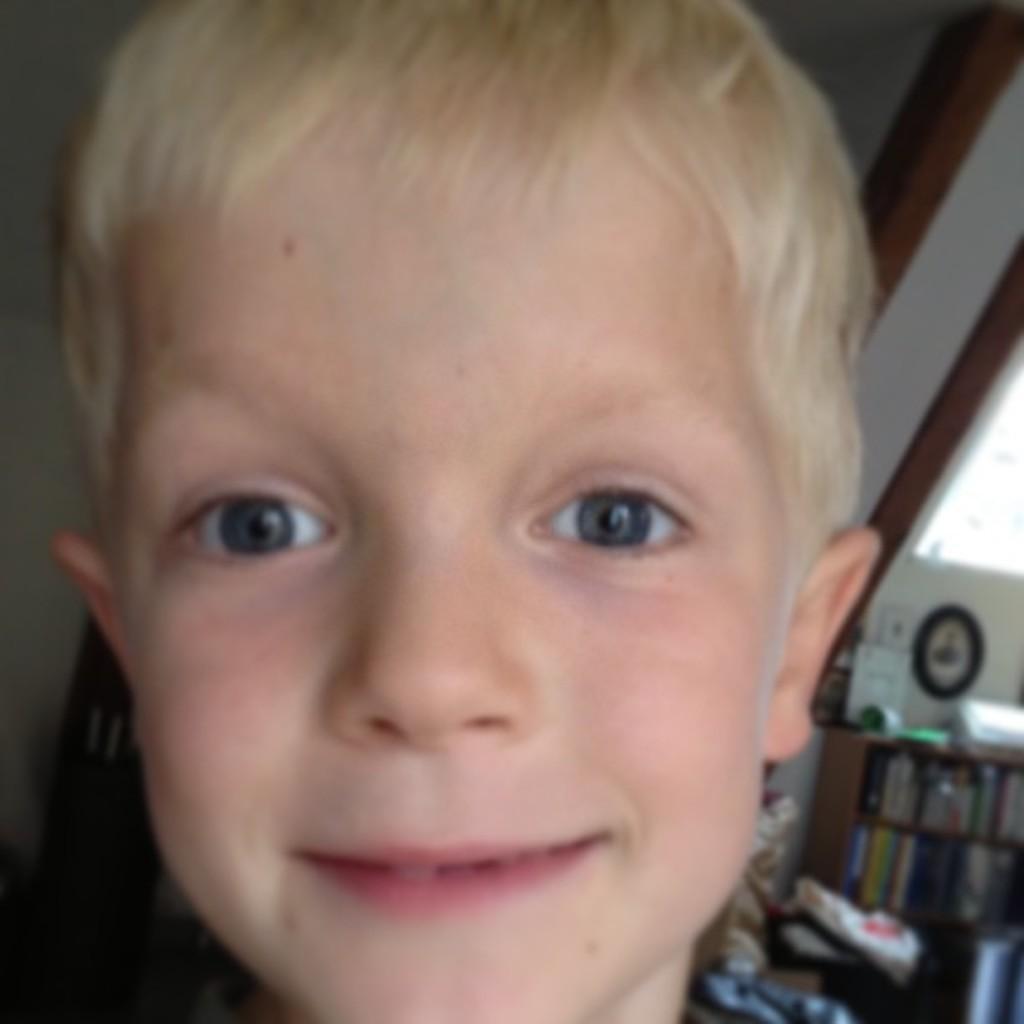Can you describe this image briefly? In this image I can see the person. In the background I can see the rack with books, some objects and many papers. 